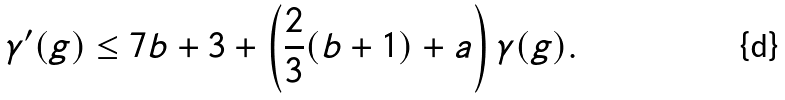<formula> <loc_0><loc_0><loc_500><loc_500>\gamma ^ { \prime } ( g ) \leq 7 b + 3 + \left ( \frac { 2 } { 3 } ( b + 1 ) + a \right ) \gamma ( g ) .</formula> 